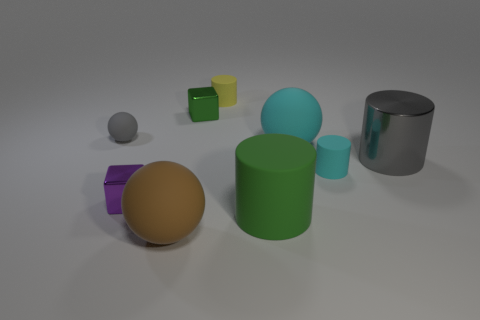Subtract all large rubber spheres. How many spheres are left? 1 Subtract 3 cylinders. How many cylinders are left? 1 Subtract all cubes. How many objects are left? 7 Subtract all purple balls. Subtract all green cylinders. How many balls are left? 3 Subtract all purple blocks. How many yellow cylinders are left? 1 Subtract all cyan spheres. Subtract all big brown rubber things. How many objects are left? 7 Add 2 tiny cyan objects. How many tiny cyan objects are left? 3 Add 4 tiny yellow matte spheres. How many tiny yellow matte spheres exist? 4 Subtract all yellow cylinders. How many cylinders are left? 3 Subtract 0 blue cylinders. How many objects are left? 9 